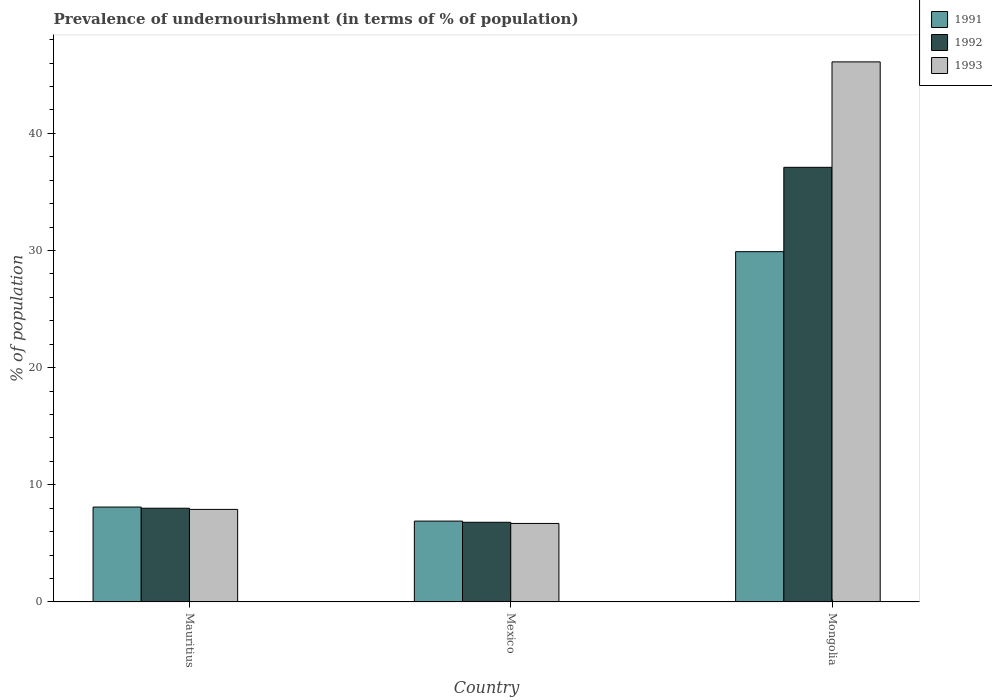How many different coloured bars are there?
Offer a very short reply. 3. How many groups of bars are there?
Offer a very short reply. 3. How many bars are there on the 2nd tick from the right?
Provide a short and direct response. 3. What is the label of the 1st group of bars from the left?
Offer a terse response. Mauritius. In how many cases, is the number of bars for a given country not equal to the number of legend labels?
Offer a very short reply. 0. Across all countries, what is the maximum percentage of undernourished population in 1992?
Offer a very short reply. 37.1. In which country was the percentage of undernourished population in 1992 maximum?
Keep it short and to the point. Mongolia. What is the total percentage of undernourished population in 1993 in the graph?
Offer a terse response. 60.7. What is the difference between the percentage of undernourished population in 1992 in Mexico and that in Mongolia?
Give a very brief answer. -30.3. What is the difference between the percentage of undernourished population in 1993 in Mauritius and the percentage of undernourished population in 1991 in Mexico?
Keep it short and to the point. 1. What is the average percentage of undernourished population in 1991 per country?
Provide a succinct answer. 14.97. What is the difference between the percentage of undernourished population of/in 1991 and percentage of undernourished population of/in 1992 in Mexico?
Give a very brief answer. 0.1. What is the ratio of the percentage of undernourished population in 1993 in Mauritius to that in Mexico?
Offer a terse response. 1.18. Is the percentage of undernourished population in 1993 in Mexico less than that in Mongolia?
Your answer should be compact. Yes. Is the difference between the percentage of undernourished population in 1991 in Mexico and Mongolia greater than the difference between the percentage of undernourished population in 1992 in Mexico and Mongolia?
Your answer should be very brief. Yes. What is the difference between the highest and the second highest percentage of undernourished population in 1991?
Your response must be concise. -21.8. What is the difference between the highest and the lowest percentage of undernourished population in 1993?
Offer a very short reply. 39.4. Is the sum of the percentage of undernourished population in 1992 in Mexico and Mongolia greater than the maximum percentage of undernourished population in 1991 across all countries?
Offer a very short reply. Yes. What does the 3rd bar from the left in Mauritius represents?
Offer a very short reply. 1993. How many countries are there in the graph?
Ensure brevity in your answer.  3. Does the graph contain any zero values?
Your answer should be compact. No. Does the graph contain grids?
Provide a succinct answer. No. How many legend labels are there?
Ensure brevity in your answer.  3. How are the legend labels stacked?
Provide a short and direct response. Vertical. What is the title of the graph?
Make the answer very short. Prevalence of undernourishment (in terms of % of population). What is the label or title of the Y-axis?
Offer a very short reply. % of population. What is the % of population in 1993 in Mauritius?
Give a very brief answer. 7.9. What is the % of population in 1991 in Mexico?
Give a very brief answer. 6.9. What is the % of population in 1991 in Mongolia?
Make the answer very short. 29.9. What is the % of population in 1992 in Mongolia?
Offer a terse response. 37.1. What is the % of population of 1993 in Mongolia?
Your answer should be very brief. 46.1. Across all countries, what is the maximum % of population in 1991?
Provide a succinct answer. 29.9. Across all countries, what is the maximum % of population in 1992?
Ensure brevity in your answer.  37.1. Across all countries, what is the maximum % of population in 1993?
Your answer should be very brief. 46.1. Across all countries, what is the minimum % of population in 1991?
Your answer should be very brief. 6.9. What is the total % of population in 1991 in the graph?
Provide a short and direct response. 44.9. What is the total % of population in 1992 in the graph?
Make the answer very short. 51.9. What is the total % of population of 1993 in the graph?
Offer a very short reply. 60.7. What is the difference between the % of population of 1992 in Mauritius and that in Mexico?
Offer a terse response. 1.2. What is the difference between the % of population in 1993 in Mauritius and that in Mexico?
Give a very brief answer. 1.2. What is the difference between the % of population in 1991 in Mauritius and that in Mongolia?
Provide a succinct answer. -21.8. What is the difference between the % of population of 1992 in Mauritius and that in Mongolia?
Offer a terse response. -29.1. What is the difference between the % of population in 1993 in Mauritius and that in Mongolia?
Offer a terse response. -38.2. What is the difference between the % of population in 1992 in Mexico and that in Mongolia?
Give a very brief answer. -30.3. What is the difference between the % of population of 1993 in Mexico and that in Mongolia?
Keep it short and to the point. -39.4. What is the difference between the % of population in 1991 in Mauritius and the % of population in 1992 in Mexico?
Offer a very short reply. 1.3. What is the difference between the % of population in 1992 in Mauritius and the % of population in 1993 in Mexico?
Your answer should be compact. 1.3. What is the difference between the % of population in 1991 in Mauritius and the % of population in 1992 in Mongolia?
Give a very brief answer. -29. What is the difference between the % of population of 1991 in Mauritius and the % of population of 1993 in Mongolia?
Keep it short and to the point. -38. What is the difference between the % of population in 1992 in Mauritius and the % of population in 1993 in Mongolia?
Your answer should be compact. -38.1. What is the difference between the % of population in 1991 in Mexico and the % of population in 1992 in Mongolia?
Give a very brief answer. -30.2. What is the difference between the % of population of 1991 in Mexico and the % of population of 1993 in Mongolia?
Make the answer very short. -39.2. What is the difference between the % of population of 1992 in Mexico and the % of population of 1993 in Mongolia?
Ensure brevity in your answer.  -39.3. What is the average % of population in 1991 per country?
Make the answer very short. 14.97. What is the average % of population of 1992 per country?
Your answer should be very brief. 17.3. What is the average % of population in 1993 per country?
Keep it short and to the point. 20.23. What is the difference between the % of population in 1991 and % of population in 1992 in Mexico?
Offer a very short reply. 0.1. What is the difference between the % of population in 1991 and % of population in 1993 in Mongolia?
Make the answer very short. -16.2. What is the ratio of the % of population in 1991 in Mauritius to that in Mexico?
Give a very brief answer. 1.17. What is the ratio of the % of population in 1992 in Mauritius to that in Mexico?
Ensure brevity in your answer.  1.18. What is the ratio of the % of population of 1993 in Mauritius to that in Mexico?
Give a very brief answer. 1.18. What is the ratio of the % of population of 1991 in Mauritius to that in Mongolia?
Your answer should be very brief. 0.27. What is the ratio of the % of population of 1992 in Mauritius to that in Mongolia?
Provide a succinct answer. 0.22. What is the ratio of the % of population in 1993 in Mauritius to that in Mongolia?
Your answer should be compact. 0.17. What is the ratio of the % of population of 1991 in Mexico to that in Mongolia?
Keep it short and to the point. 0.23. What is the ratio of the % of population of 1992 in Mexico to that in Mongolia?
Make the answer very short. 0.18. What is the ratio of the % of population of 1993 in Mexico to that in Mongolia?
Your answer should be very brief. 0.15. What is the difference between the highest and the second highest % of population in 1991?
Offer a very short reply. 21.8. What is the difference between the highest and the second highest % of population in 1992?
Your response must be concise. 29.1. What is the difference between the highest and the second highest % of population in 1993?
Provide a succinct answer. 38.2. What is the difference between the highest and the lowest % of population of 1991?
Offer a very short reply. 23. What is the difference between the highest and the lowest % of population of 1992?
Ensure brevity in your answer.  30.3. What is the difference between the highest and the lowest % of population in 1993?
Your answer should be compact. 39.4. 